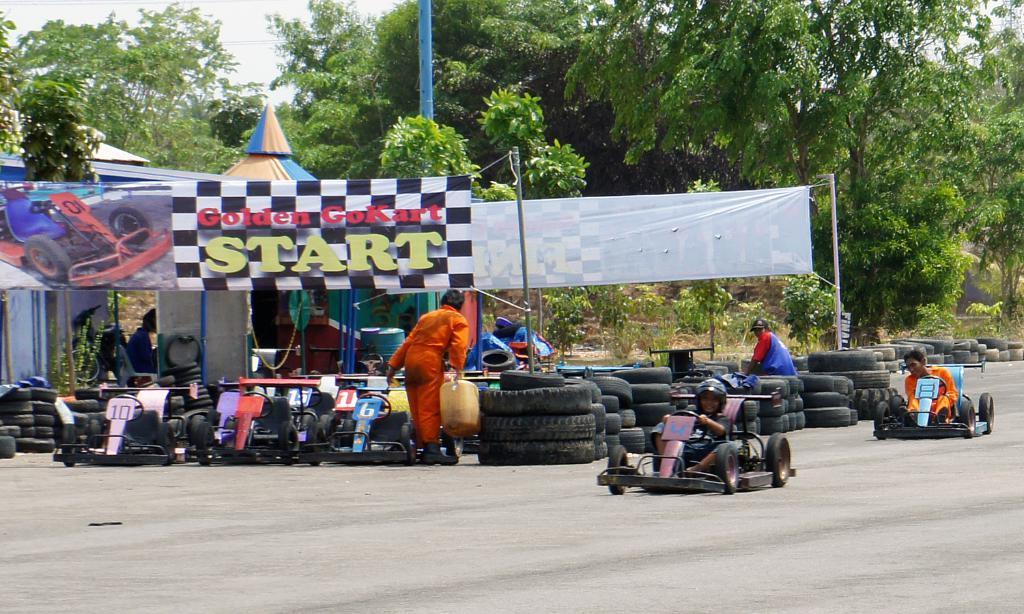Can you describe this image briefly? These two persons are sitting and riding vehicle and this person sitting on the tyre,this person standing and holding can. We can see tyres,vehicles,trees,sky,banners. 